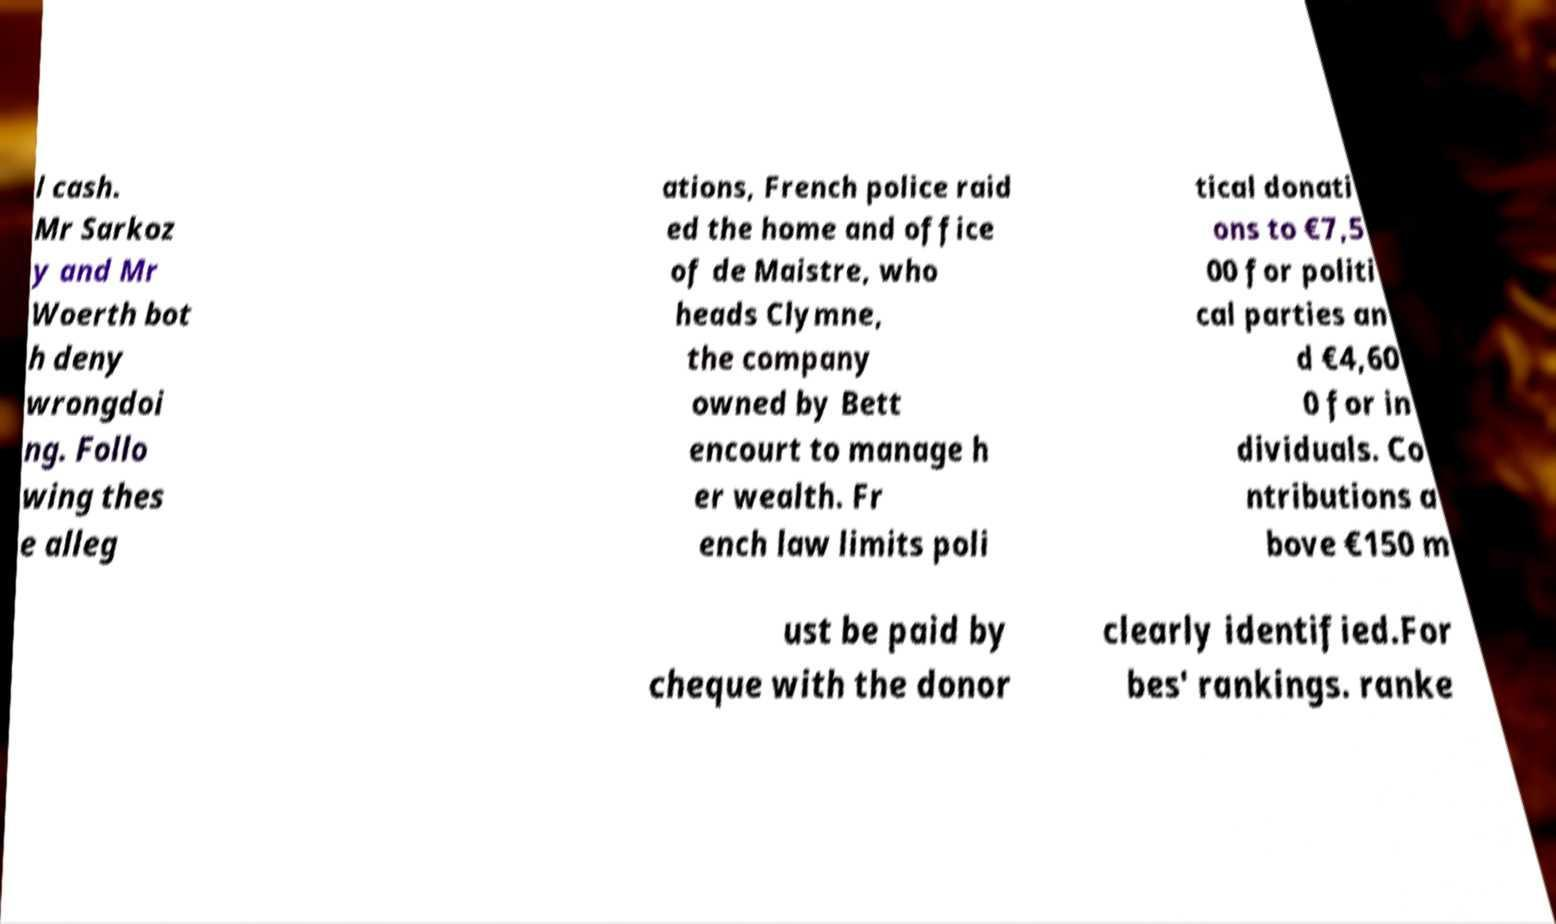What messages or text are displayed in this image? I need them in a readable, typed format. l cash. Mr Sarkoz y and Mr Woerth bot h deny wrongdoi ng. Follo wing thes e alleg ations, French police raid ed the home and office of de Maistre, who heads Clymne, the company owned by Bett encourt to manage h er wealth. Fr ench law limits poli tical donati ons to €7,5 00 for politi cal parties an d €4,60 0 for in dividuals. Co ntributions a bove €150 m ust be paid by cheque with the donor clearly identified.For bes' rankings. ranke 